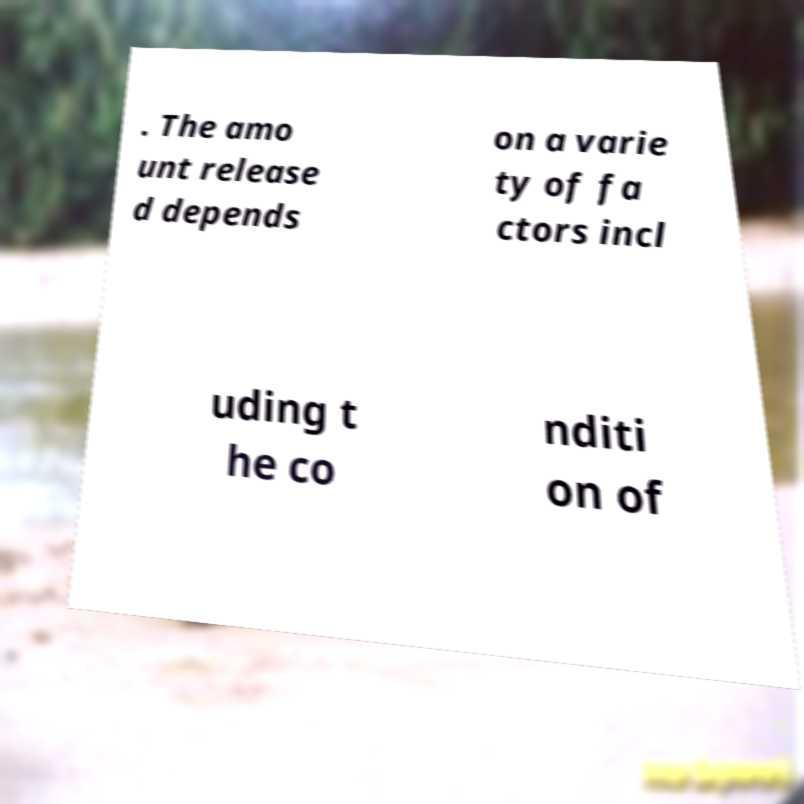Could you extract and type out the text from this image? . The amo unt release d depends on a varie ty of fa ctors incl uding t he co nditi on of 